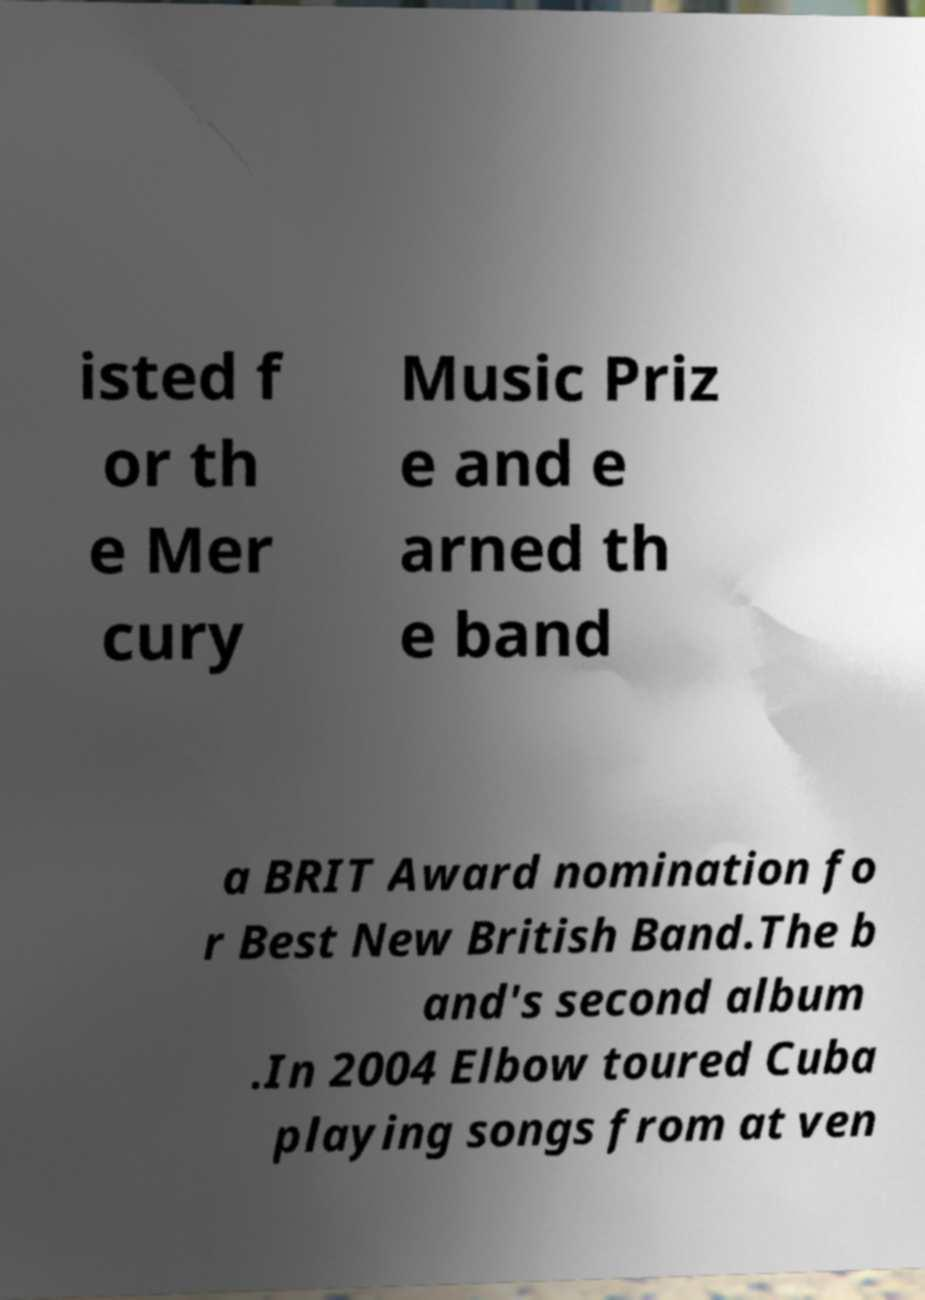Could you extract and type out the text from this image? isted f or th e Mer cury Music Priz e and e arned th e band a BRIT Award nomination fo r Best New British Band.The b and's second album .In 2004 Elbow toured Cuba playing songs from at ven 